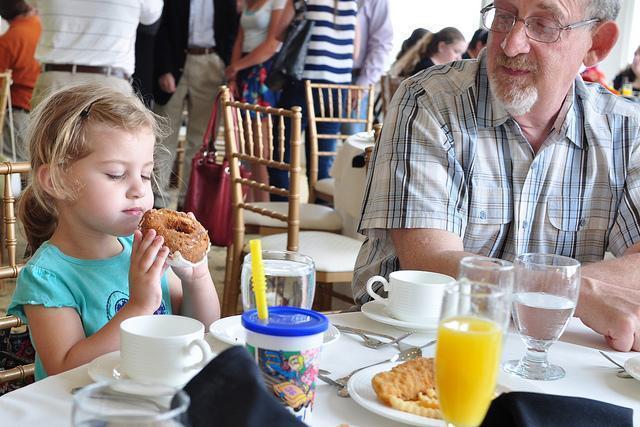How many wine glasses are visible?
Give a very brief answer. 3. How many people are in the photo?
Give a very brief answer. 8. How many cups are there?
Give a very brief answer. 4. How many chairs are there?
Give a very brief answer. 3. How many human statues are to the left of the clock face?
Give a very brief answer. 0. 